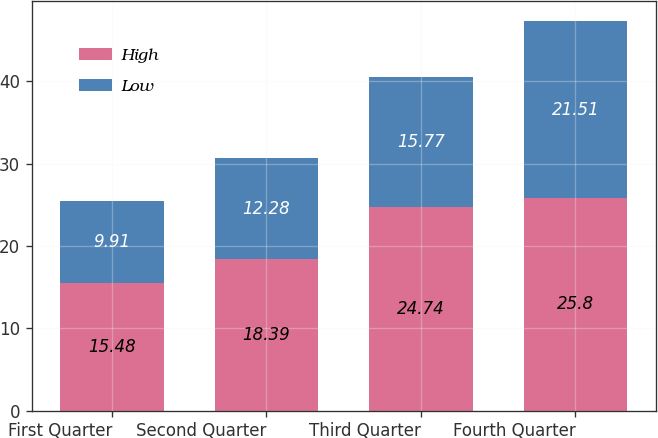<chart> <loc_0><loc_0><loc_500><loc_500><stacked_bar_chart><ecel><fcel>First Quarter<fcel>Second Quarter<fcel>Third Quarter<fcel>Fourth Quarter<nl><fcel>High<fcel>15.48<fcel>18.39<fcel>24.74<fcel>25.8<nl><fcel>Low<fcel>9.91<fcel>12.28<fcel>15.77<fcel>21.51<nl></chart> 